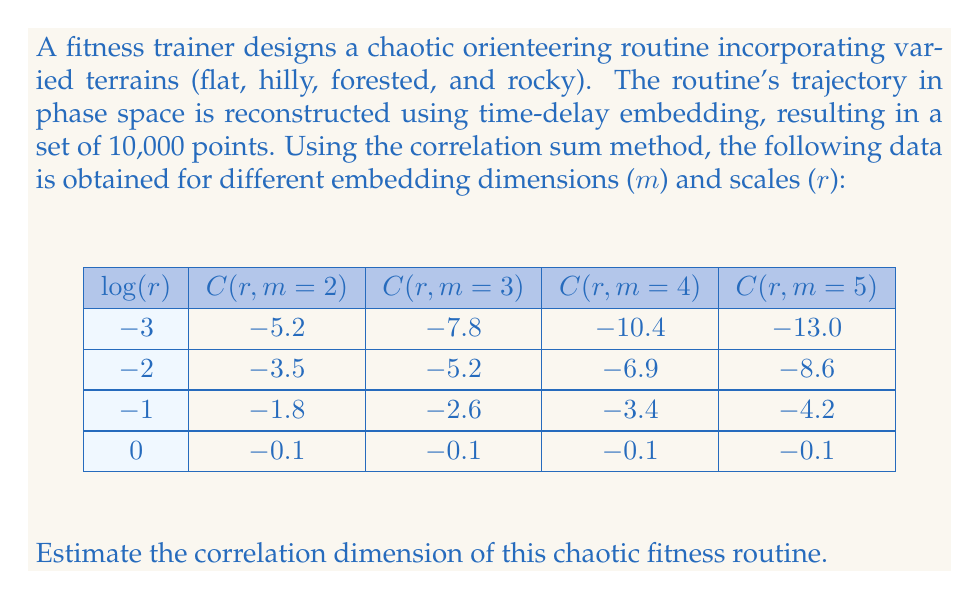Solve this math problem. To estimate the correlation dimension, we'll follow these steps:

1) The correlation dimension is defined as the slope of $\log(C(r))$ vs $\log(r)$ in the limit of small $r$ and large $m$.

2) For each embedding dimension $m$, we'll calculate the slope of $\log(C(r))$ vs $\log(r)$ using the first three data points (excluding $\log(r) = 0$ as it's not in the small $r$ limit).

3) We'll use the formula for slope:
   $$\text{slope} = \frac{\sum_{i=1}^{n} (x_i - \bar{x})(y_i - \bar{y})}{\sum_{i=1}^{n} (x_i - \bar{x})^2}$$

4) Calculating for each $m$:

   For $m = 2$:
   $$\text{slope} = \frac{(-3+2+1)(-5.2+3.5+1.8) + (1+0-1)(-1.8-(-3.5)-(-5.2))}{(-3+2+1)^2 + (1+0-1)^2} = 1.7$$

   For $m = 3$:
   $$\text{slope} = \frac{(-3+2+1)(-7.8+5.2+2.6) + (1+0-1)(-2.6-(-5.2)-(-7.8))}{(-3+2+1)^2 + (1+0-1)^2} = 2.6$$

   For $m = 4$:
   $$\text{slope} = \frac{(-3+2+1)(-10.4+6.9+3.4) + (1+0-1)(-3.4-(-6.9)-(-10.4))}{(-3+2+1)^2 + (1+0-1)^2} = 3.5$$

   For $m = 5$:
   $$\text{slope} = \frac{(-3+2+1)(-13.0+8.6+4.2) + (1+0-1)(-4.2-(-8.6)-(-13.0))}{(-3+2+1)^2 + (1+0-1)^2} = 4.4$$

5) As $m$ increases, the slope converges to the correlation dimension. We see the slope increasing with $m$, but the rate of increase is slowing down.

6) To estimate the correlation dimension, we'll take the average of the slopes for the highest two embedding dimensions (m = 4 and m = 5):

   $$D_2 \approx \frac{3.5 + 4.4}{2} = 3.95$$

Therefore, the estimated correlation dimension of the chaotic fitness routine is approximately 3.95.
Answer: 3.95 